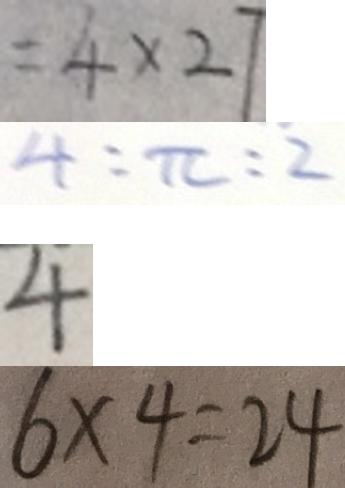<formula> <loc_0><loc_0><loc_500><loc_500>= 4 \times 2 7 
 4 : \pi : 2 
 4 
 6 \times 4 = 2 4</formula> 